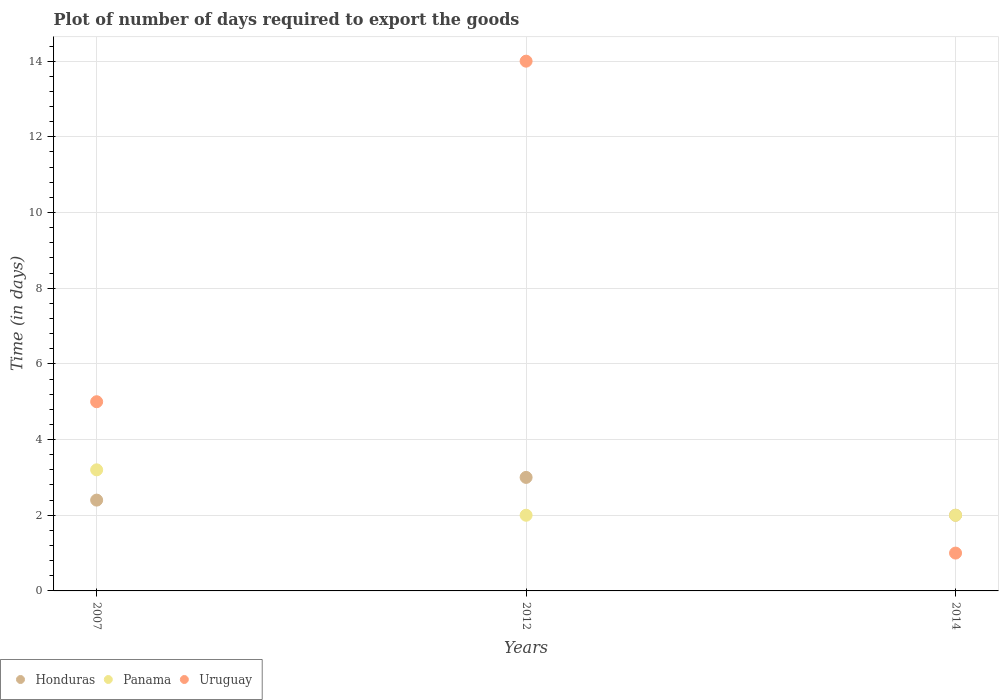Is the number of dotlines equal to the number of legend labels?
Keep it short and to the point. Yes. Across all years, what is the maximum time required to export goods in Panama?
Provide a short and direct response. 3.2. Across all years, what is the minimum time required to export goods in Panama?
Provide a succinct answer. 2. In which year was the time required to export goods in Uruguay maximum?
Offer a terse response. 2012. What is the total time required to export goods in Uruguay in the graph?
Provide a succinct answer. 20. What is the difference between the time required to export goods in Honduras in 2007 and that in 2014?
Your answer should be very brief. 0.4. What is the difference between the time required to export goods in Honduras in 2014 and the time required to export goods in Uruguay in 2012?
Give a very brief answer. -12. What is the average time required to export goods in Honduras per year?
Your response must be concise. 2.47. What is the ratio of the time required to export goods in Uruguay in 2007 to that in 2014?
Offer a very short reply. 5. Is the time required to export goods in Honduras in 2012 less than that in 2014?
Offer a very short reply. No. What is the difference between the highest and the second highest time required to export goods in Honduras?
Provide a short and direct response. 0.6. What is the difference between the highest and the lowest time required to export goods in Uruguay?
Your answer should be very brief. 13. In how many years, is the time required to export goods in Panama greater than the average time required to export goods in Panama taken over all years?
Make the answer very short. 1. Is it the case that in every year, the sum of the time required to export goods in Panama and time required to export goods in Uruguay  is greater than the time required to export goods in Honduras?
Make the answer very short. Yes. Does the time required to export goods in Honduras monotonically increase over the years?
Provide a short and direct response. No. Is the time required to export goods in Uruguay strictly greater than the time required to export goods in Panama over the years?
Give a very brief answer. No. Is the time required to export goods in Uruguay strictly less than the time required to export goods in Panama over the years?
Ensure brevity in your answer.  No. Does the graph contain any zero values?
Keep it short and to the point. No. Where does the legend appear in the graph?
Make the answer very short. Bottom left. How are the legend labels stacked?
Your answer should be compact. Horizontal. What is the title of the graph?
Your response must be concise. Plot of number of days required to export the goods. Does "Bhutan" appear as one of the legend labels in the graph?
Provide a short and direct response. No. What is the label or title of the X-axis?
Provide a succinct answer. Years. What is the label or title of the Y-axis?
Your answer should be compact. Time (in days). What is the Time (in days) of Honduras in 2007?
Ensure brevity in your answer.  2.4. What is the Time (in days) of Panama in 2007?
Provide a short and direct response. 3.2. What is the Time (in days) of Uruguay in 2007?
Provide a short and direct response. 5. What is the Time (in days) of Honduras in 2014?
Offer a terse response. 2. What is the Time (in days) in Uruguay in 2014?
Offer a very short reply. 1. Across all years, what is the minimum Time (in days) of Panama?
Offer a terse response. 2. Across all years, what is the minimum Time (in days) in Uruguay?
Keep it short and to the point. 1. What is the total Time (in days) of Honduras in the graph?
Your response must be concise. 7.4. What is the difference between the Time (in days) in Uruguay in 2007 and that in 2012?
Keep it short and to the point. -9. What is the difference between the Time (in days) of Panama in 2007 and that in 2014?
Your answer should be compact. 1.2. What is the difference between the Time (in days) of Honduras in 2012 and that in 2014?
Keep it short and to the point. 1. What is the difference between the Time (in days) of Uruguay in 2012 and that in 2014?
Ensure brevity in your answer.  13. What is the difference between the Time (in days) of Honduras in 2007 and the Time (in days) of Panama in 2012?
Offer a very short reply. 0.4. What is the difference between the Time (in days) of Honduras in 2007 and the Time (in days) of Panama in 2014?
Ensure brevity in your answer.  0.4. What is the difference between the Time (in days) in Honduras in 2007 and the Time (in days) in Uruguay in 2014?
Provide a succinct answer. 1.4. What is the difference between the Time (in days) of Panama in 2007 and the Time (in days) of Uruguay in 2014?
Your answer should be very brief. 2.2. What is the difference between the Time (in days) of Honduras in 2012 and the Time (in days) of Panama in 2014?
Your answer should be very brief. 1. What is the difference between the Time (in days) in Honduras in 2012 and the Time (in days) in Uruguay in 2014?
Your response must be concise. 2. What is the average Time (in days) of Honduras per year?
Your response must be concise. 2.47. What is the average Time (in days) of Panama per year?
Keep it short and to the point. 2.4. What is the average Time (in days) in Uruguay per year?
Your response must be concise. 6.67. In the year 2007, what is the difference between the Time (in days) of Honduras and Time (in days) of Uruguay?
Give a very brief answer. -2.6. In the year 2007, what is the difference between the Time (in days) of Panama and Time (in days) of Uruguay?
Offer a very short reply. -1.8. In the year 2012, what is the difference between the Time (in days) of Honduras and Time (in days) of Panama?
Offer a very short reply. 1. In the year 2012, what is the difference between the Time (in days) of Honduras and Time (in days) of Uruguay?
Give a very brief answer. -11. In the year 2012, what is the difference between the Time (in days) of Panama and Time (in days) of Uruguay?
Your response must be concise. -12. In the year 2014, what is the difference between the Time (in days) of Panama and Time (in days) of Uruguay?
Offer a terse response. 1. What is the ratio of the Time (in days) of Panama in 2007 to that in 2012?
Your response must be concise. 1.6. What is the ratio of the Time (in days) in Uruguay in 2007 to that in 2012?
Keep it short and to the point. 0.36. What is the ratio of the Time (in days) of Honduras in 2007 to that in 2014?
Your answer should be compact. 1.2. What is the ratio of the Time (in days) of Panama in 2007 to that in 2014?
Keep it short and to the point. 1.6. What is the ratio of the Time (in days) in Honduras in 2012 to that in 2014?
Provide a short and direct response. 1.5. What is the difference between the highest and the second highest Time (in days) in Honduras?
Make the answer very short. 0.6. What is the difference between the highest and the lowest Time (in days) of Panama?
Offer a very short reply. 1.2. What is the difference between the highest and the lowest Time (in days) of Uruguay?
Provide a short and direct response. 13. 